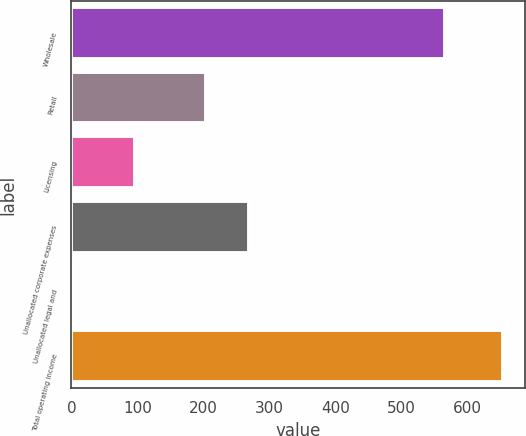<chart> <loc_0><loc_0><loc_500><loc_500><bar_chart><fcel>Wholesale<fcel>Retail<fcel>Licensing<fcel>Unallocated corporate expenses<fcel>Unallocated legal and<fcel>Total operating income<nl><fcel>565.4<fcel>204.2<fcel>96.7<fcel>269.13<fcel>4.1<fcel>653.4<nl></chart> 